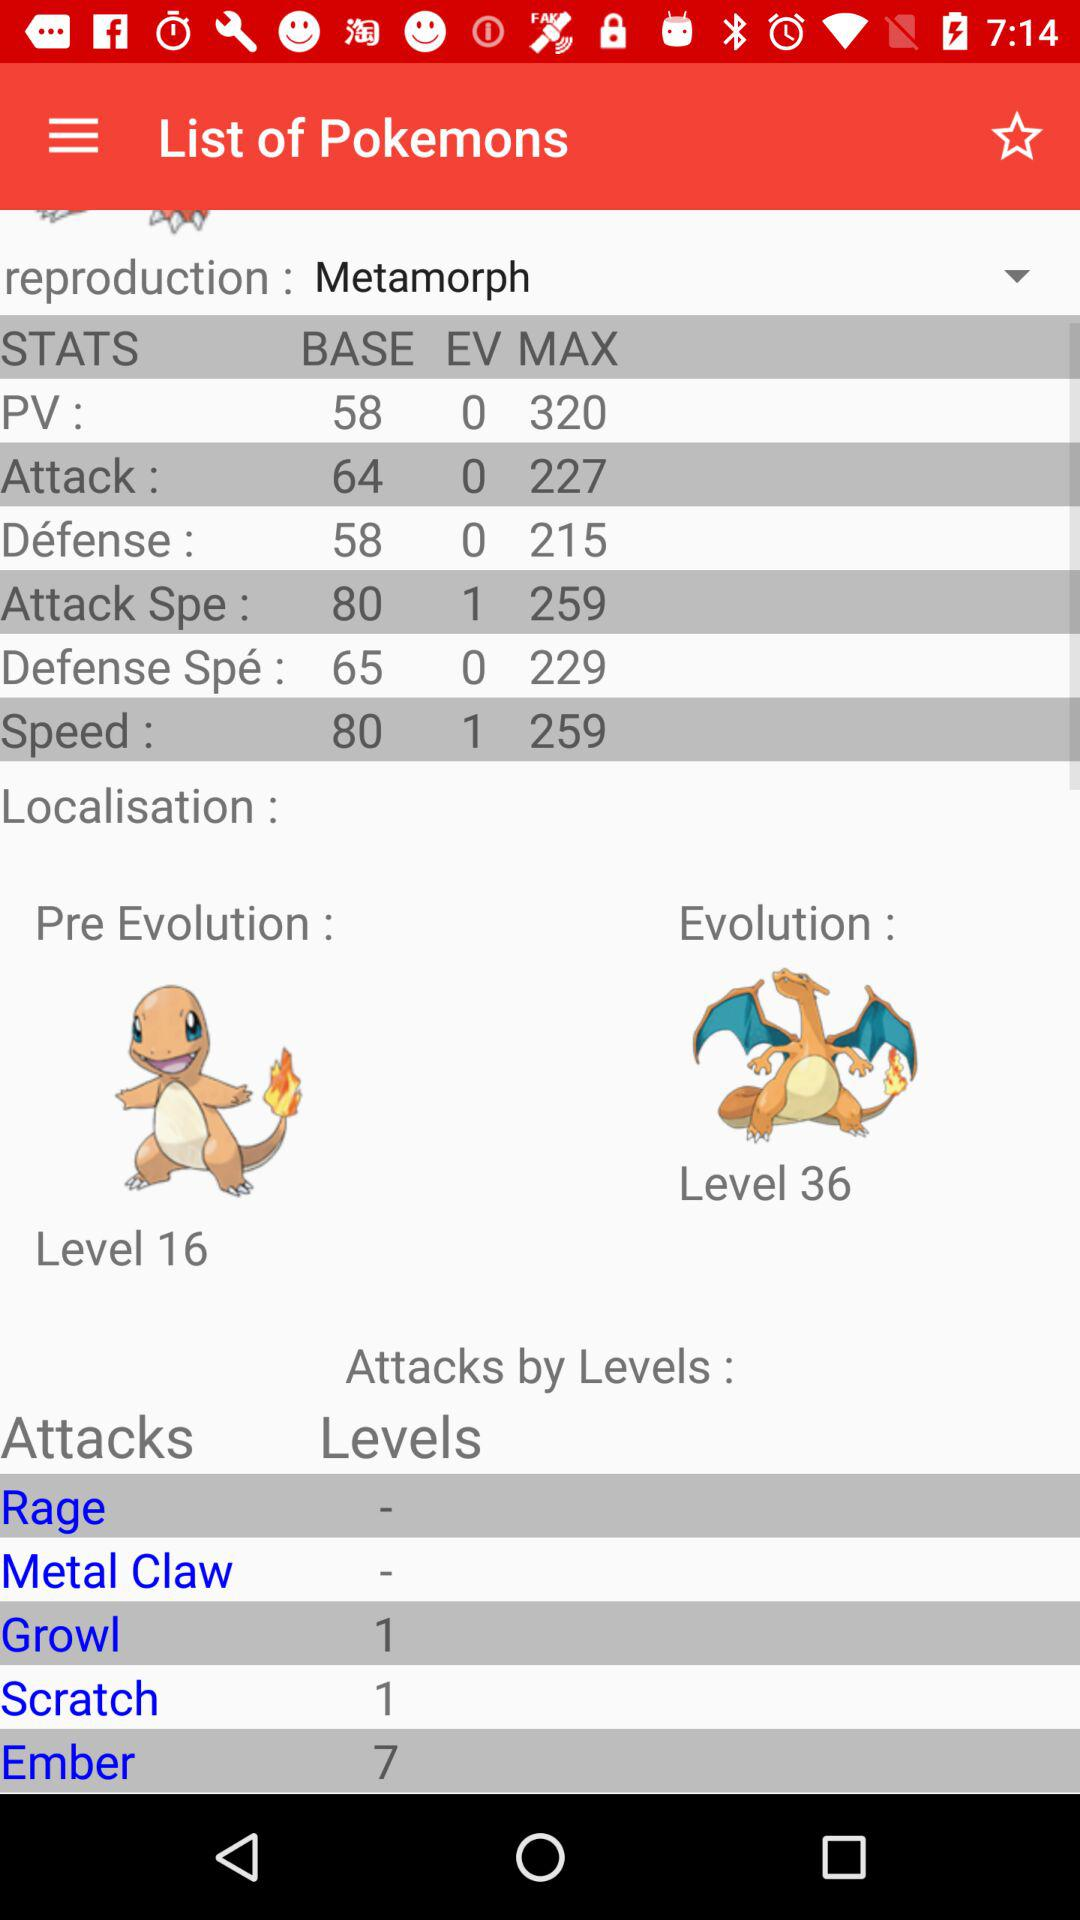What is the evolution level of the Pokemon? The evolution level of the Pokemon is 36. 